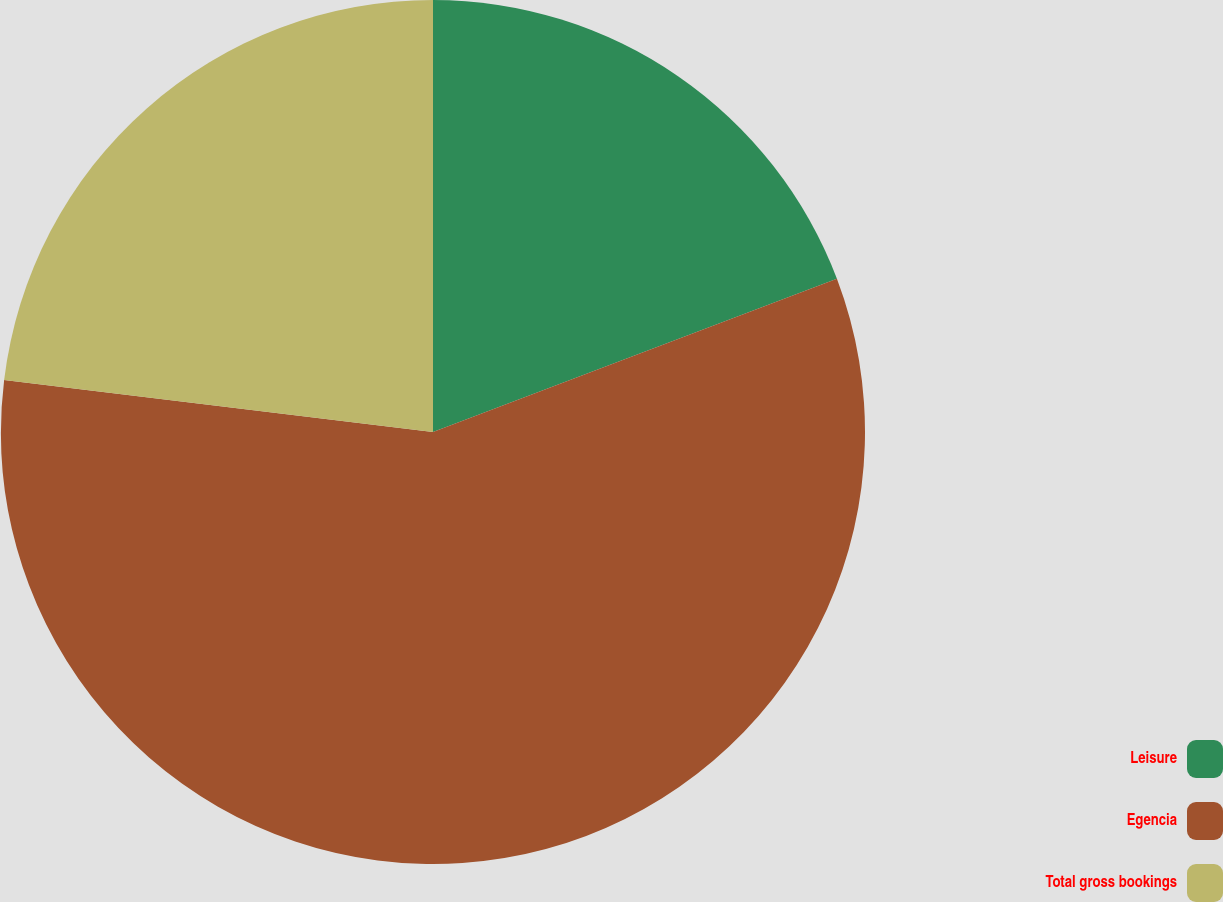Convert chart. <chart><loc_0><loc_0><loc_500><loc_500><pie_chart><fcel>Leisure<fcel>Egencia<fcel>Total gross bookings<nl><fcel>19.23%<fcel>57.69%<fcel>23.08%<nl></chart> 